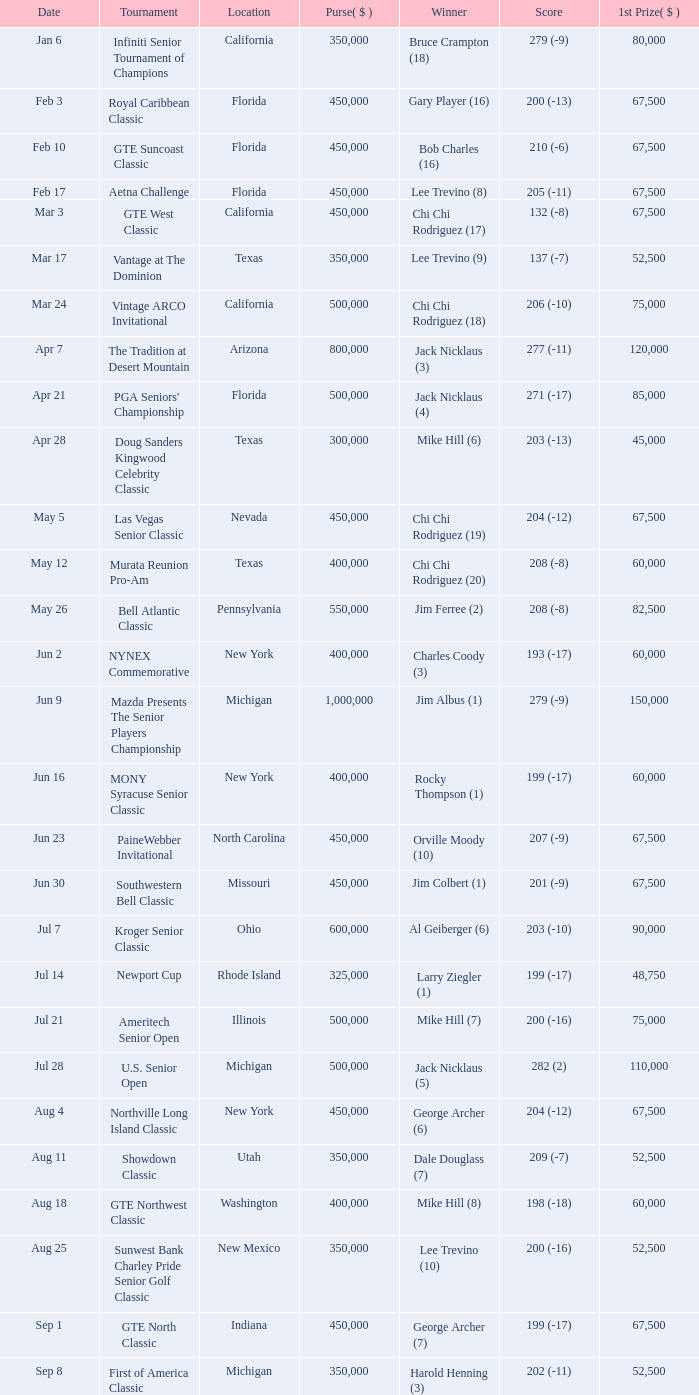For a tournament with a winning score of 212 (-4) and a first-place reward under $105,000, what is the total purse? None. 